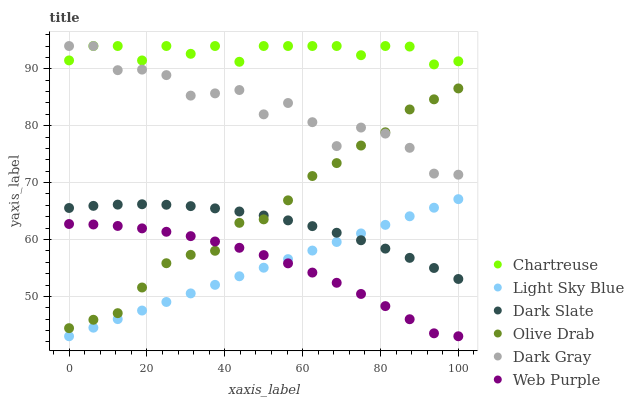Does Light Sky Blue have the minimum area under the curve?
Answer yes or no. Yes. Does Chartreuse have the maximum area under the curve?
Answer yes or no. Yes. Does Dark Gray have the minimum area under the curve?
Answer yes or no. No. Does Dark Gray have the maximum area under the curve?
Answer yes or no. No. Is Light Sky Blue the smoothest?
Answer yes or no. Yes. Is Dark Gray the roughest?
Answer yes or no. Yes. Is Dark Slate the smoothest?
Answer yes or no. No. Is Dark Slate the roughest?
Answer yes or no. No. Does Web Purple have the lowest value?
Answer yes or no. Yes. Does Dark Gray have the lowest value?
Answer yes or no. No. Does Chartreuse have the highest value?
Answer yes or no. Yes. Does Dark Slate have the highest value?
Answer yes or no. No. Is Olive Drab less than Chartreuse?
Answer yes or no. Yes. Is Dark Gray greater than Dark Slate?
Answer yes or no. Yes. Does Chartreuse intersect Dark Gray?
Answer yes or no. Yes. Is Chartreuse less than Dark Gray?
Answer yes or no. No. Is Chartreuse greater than Dark Gray?
Answer yes or no. No. Does Olive Drab intersect Chartreuse?
Answer yes or no. No. 